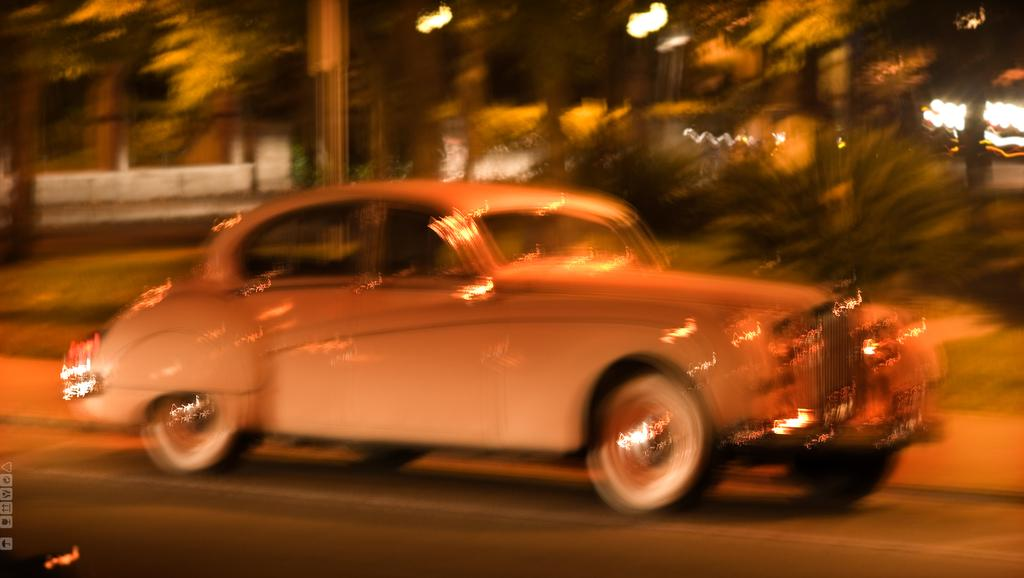What is the main subject of the image? There is a car in the image. Where is the car located? The car is on the road and at the bottom of the image. What can be seen behind the car? There are trees behind the car. What else is visible in the background? There are lights and poles in the background. What type of eggnog is being served in the car? There is no eggnog present in the image; it features a car on the road with trees and lights in the background. How do the poles in the background join together in harmony? The poles in the background are not shown to be joining together, and there is no indication of harmony in the image. 